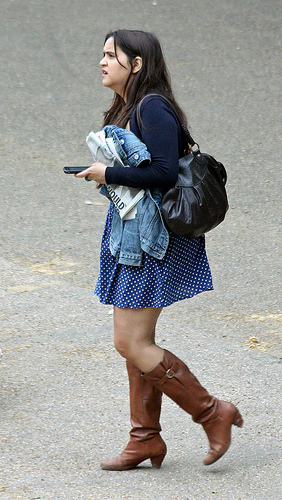Which place is this image in? The image portrays an individual walking on a pavement, which suggests an urban setting or a busy pedestrian area likely within a city or a town. 